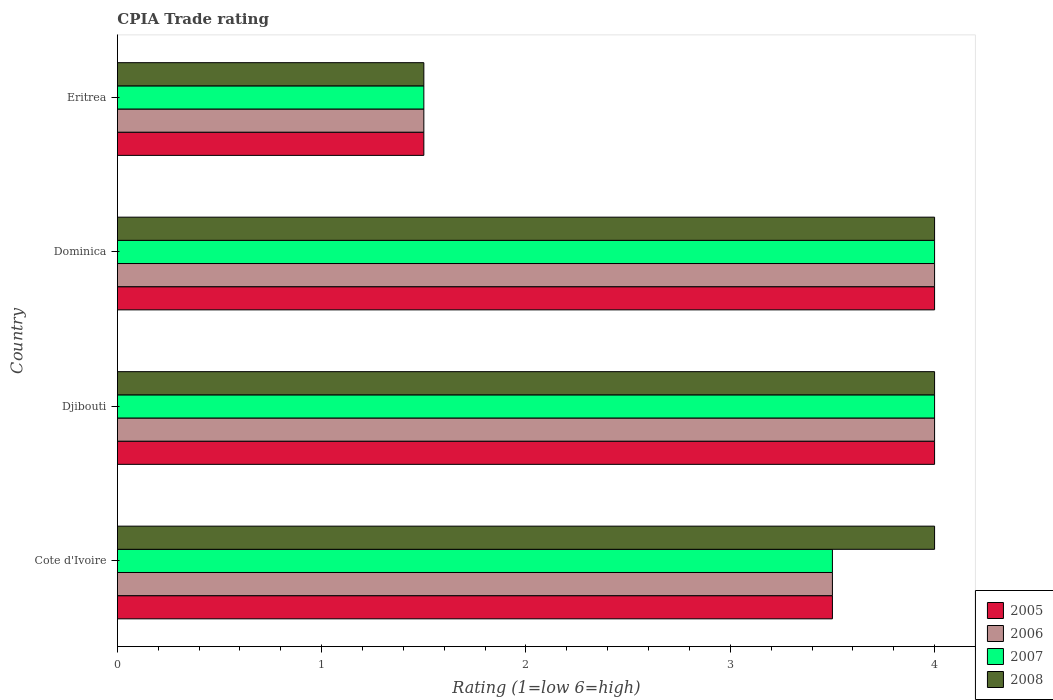How many different coloured bars are there?
Your answer should be very brief. 4. Are the number of bars on each tick of the Y-axis equal?
Give a very brief answer. Yes. How many bars are there on the 2nd tick from the top?
Your response must be concise. 4. How many bars are there on the 1st tick from the bottom?
Offer a very short reply. 4. What is the label of the 3rd group of bars from the top?
Ensure brevity in your answer.  Djibouti. What is the CPIA rating in 2007 in Cote d'Ivoire?
Your response must be concise. 3.5. In which country was the CPIA rating in 2006 maximum?
Your response must be concise. Djibouti. In which country was the CPIA rating in 2006 minimum?
Make the answer very short. Eritrea. What is the total CPIA rating in 2005 in the graph?
Keep it short and to the point. 13. What is the average CPIA rating in 2007 per country?
Your answer should be compact. 3.25. In how many countries, is the CPIA rating in 2008 greater than 3.6 ?
Offer a terse response. 3. What is the difference between the highest and the second highest CPIA rating in 2007?
Provide a short and direct response. 0. In how many countries, is the CPIA rating in 2005 greater than the average CPIA rating in 2005 taken over all countries?
Your response must be concise. 3. Is the sum of the CPIA rating in 2008 in Cote d'Ivoire and Eritrea greater than the maximum CPIA rating in 2007 across all countries?
Provide a succinct answer. Yes. Is it the case that in every country, the sum of the CPIA rating in 2007 and CPIA rating in 2006 is greater than the sum of CPIA rating in 2008 and CPIA rating in 2005?
Keep it short and to the point. No. What does the 4th bar from the top in Dominica represents?
Ensure brevity in your answer.  2005. How many bars are there?
Keep it short and to the point. 16. Are the values on the major ticks of X-axis written in scientific E-notation?
Offer a very short reply. No. Does the graph contain any zero values?
Offer a terse response. No. Where does the legend appear in the graph?
Provide a succinct answer. Bottom right. How many legend labels are there?
Your answer should be very brief. 4. How are the legend labels stacked?
Make the answer very short. Vertical. What is the title of the graph?
Keep it short and to the point. CPIA Trade rating. What is the label or title of the X-axis?
Offer a very short reply. Rating (1=low 6=high). What is the Rating (1=low 6=high) of 2008 in Cote d'Ivoire?
Provide a short and direct response. 4. What is the Rating (1=low 6=high) of 2007 in Djibouti?
Provide a succinct answer. 4. What is the Rating (1=low 6=high) in 2005 in Dominica?
Your response must be concise. 4. What is the Rating (1=low 6=high) in 2007 in Dominica?
Ensure brevity in your answer.  4. What is the Rating (1=low 6=high) in 2008 in Dominica?
Your response must be concise. 4. What is the Rating (1=low 6=high) in 2006 in Eritrea?
Your answer should be compact. 1.5. What is the Rating (1=low 6=high) in 2007 in Eritrea?
Provide a succinct answer. 1.5. What is the Rating (1=low 6=high) of 2008 in Eritrea?
Offer a very short reply. 1.5. Across all countries, what is the maximum Rating (1=low 6=high) of 2005?
Your answer should be very brief. 4. Across all countries, what is the maximum Rating (1=low 6=high) of 2007?
Your answer should be very brief. 4. What is the total Rating (1=low 6=high) in 2005 in the graph?
Ensure brevity in your answer.  13. What is the total Rating (1=low 6=high) of 2008 in the graph?
Provide a short and direct response. 13.5. What is the difference between the Rating (1=low 6=high) of 2005 in Cote d'Ivoire and that in Djibouti?
Give a very brief answer. -0.5. What is the difference between the Rating (1=low 6=high) in 2006 in Cote d'Ivoire and that in Djibouti?
Your answer should be very brief. -0.5. What is the difference between the Rating (1=low 6=high) in 2008 in Cote d'Ivoire and that in Djibouti?
Offer a very short reply. 0. What is the difference between the Rating (1=low 6=high) of 2005 in Cote d'Ivoire and that in Dominica?
Give a very brief answer. -0.5. What is the difference between the Rating (1=low 6=high) of 2007 in Cote d'Ivoire and that in Dominica?
Ensure brevity in your answer.  -0.5. What is the difference between the Rating (1=low 6=high) in 2008 in Cote d'Ivoire and that in Dominica?
Your response must be concise. 0. What is the difference between the Rating (1=low 6=high) of 2007 in Cote d'Ivoire and that in Eritrea?
Keep it short and to the point. 2. What is the difference between the Rating (1=low 6=high) in 2008 in Cote d'Ivoire and that in Eritrea?
Provide a short and direct response. 2.5. What is the difference between the Rating (1=low 6=high) in 2005 in Djibouti and that in Dominica?
Your answer should be very brief. 0. What is the difference between the Rating (1=low 6=high) of 2006 in Djibouti and that in Dominica?
Give a very brief answer. 0. What is the difference between the Rating (1=low 6=high) of 2007 in Djibouti and that in Dominica?
Keep it short and to the point. 0. What is the difference between the Rating (1=low 6=high) in 2008 in Djibouti and that in Dominica?
Ensure brevity in your answer.  0. What is the difference between the Rating (1=low 6=high) of 2005 in Djibouti and that in Eritrea?
Make the answer very short. 2.5. What is the difference between the Rating (1=low 6=high) in 2006 in Djibouti and that in Eritrea?
Keep it short and to the point. 2.5. What is the difference between the Rating (1=low 6=high) of 2008 in Djibouti and that in Eritrea?
Ensure brevity in your answer.  2.5. What is the difference between the Rating (1=low 6=high) of 2005 in Dominica and that in Eritrea?
Offer a very short reply. 2.5. What is the difference between the Rating (1=low 6=high) in 2007 in Dominica and that in Eritrea?
Provide a succinct answer. 2.5. What is the difference between the Rating (1=low 6=high) of 2008 in Dominica and that in Eritrea?
Give a very brief answer. 2.5. What is the difference between the Rating (1=low 6=high) of 2005 in Cote d'Ivoire and the Rating (1=low 6=high) of 2006 in Djibouti?
Give a very brief answer. -0.5. What is the difference between the Rating (1=low 6=high) in 2005 in Cote d'Ivoire and the Rating (1=low 6=high) in 2007 in Djibouti?
Your response must be concise. -0.5. What is the difference between the Rating (1=low 6=high) in 2006 in Cote d'Ivoire and the Rating (1=low 6=high) in 2007 in Djibouti?
Your answer should be compact. -0.5. What is the difference between the Rating (1=low 6=high) of 2005 in Cote d'Ivoire and the Rating (1=low 6=high) of 2006 in Dominica?
Give a very brief answer. -0.5. What is the difference between the Rating (1=low 6=high) in 2005 in Cote d'Ivoire and the Rating (1=low 6=high) in 2007 in Dominica?
Keep it short and to the point. -0.5. What is the difference between the Rating (1=low 6=high) in 2005 in Cote d'Ivoire and the Rating (1=low 6=high) in 2008 in Dominica?
Provide a succinct answer. -0.5. What is the difference between the Rating (1=low 6=high) of 2006 in Cote d'Ivoire and the Rating (1=low 6=high) of 2007 in Dominica?
Your answer should be very brief. -0.5. What is the difference between the Rating (1=low 6=high) in 2006 in Cote d'Ivoire and the Rating (1=low 6=high) in 2008 in Dominica?
Offer a very short reply. -0.5. What is the difference between the Rating (1=low 6=high) of 2007 in Cote d'Ivoire and the Rating (1=low 6=high) of 2008 in Dominica?
Your answer should be compact. -0.5. What is the difference between the Rating (1=low 6=high) in 2005 in Cote d'Ivoire and the Rating (1=low 6=high) in 2007 in Eritrea?
Your response must be concise. 2. What is the difference between the Rating (1=low 6=high) of 2006 in Cote d'Ivoire and the Rating (1=low 6=high) of 2007 in Eritrea?
Give a very brief answer. 2. What is the difference between the Rating (1=low 6=high) in 2006 in Cote d'Ivoire and the Rating (1=low 6=high) in 2008 in Eritrea?
Your response must be concise. 2. What is the difference between the Rating (1=low 6=high) in 2007 in Cote d'Ivoire and the Rating (1=low 6=high) in 2008 in Eritrea?
Provide a succinct answer. 2. What is the difference between the Rating (1=low 6=high) in 2005 in Djibouti and the Rating (1=low 6=high) in 2006 in Dominica?
Your answer should be very brief. 0. What is the difference between the Rating (1=low 6=high) in 2005 in Djibouti and the Rating (1=low 6=high) in 2007 in Dominica?
Provide a short and direct response. 0. What is the difference between the Rating (1=low 6=high) in 2005 in Djibouti and the Rating (1=low 6=high) in 2008 in Dominica?
Give a very brief answer. 0. What is the difference between the Rating (1=low 6=high) of 2006 in Djibouti and the Rating (1=low 6=high) of 2007 in Dominica?
Make the answer very short. 0. What is the difference between the Rating (1=low 6=high) of 2006 in Djibouti and the Rating (1=low 6=high) of 2008 in Dominica?
Ensure brevity in your answer.  0. What is the difference between the Rating (1=low 6=high) of 2005 in Djibouti and the Rating (1=low 6=high) of 2006 in Eritrea?
Your answer should be very brief. 2.5. What is the difference between the Rating (1=low 6=high) of 2005 in Djibouti and the Rating (1=low 6=high) of 2007 in Eritrea?
Give a very brief answer. 2.5. What is the difference between the Rating (1=low 6=high) of 2005 in Djibouti and the Rating (1=low 6=high) of 2008 in Eritrea?
Provide a succinct answer. 2.5. What is the difference between the Rating (1=low 6=high) in 2006 in Djibouti and the Rating (1=low 6=high) in 2007 in Eritrea?
Provide a short and direct response. 2.5. What is the difference between the Rating (1=low 6=high) of 2006 in Djibouti and the Rating (1=low 6=high) of 2008 in Eritrea?
Make the answer very short. 2.5. What is the difference between the Rating (1=low 6=high) of 2007 in Djibouti and the Rating (1=low 6=high) of 2008 in Eritrea?
Your answer should be very brief. 2.5. What is the difference between the Rating (1=low 6=high) in 2005 in Dominica and the Rating (1=low 6=high) in 2007 in Eritrea?
Your answer should be compact. 2.5. What is the average Rating (1=low 6=high) in 2006 per country?
Provide a short and direct response. 3.25. What is the average Rating (1=low 6=high) in 2007 per country?
Provide a succinct answer. 3.25. What is the average Rating (1=low 6=high) of 2008 per country?
Keep it short and to the point. 3.38. What is the difference between the Rating (1=low 6=high) of 2005 and Rating (1=low 6=high) of 2006 in Cote d'Ivoire?
Provide a succinct answer. 0. What is the difference between the Rating (1=low 6=high) of 2005 and Rating (1=low 6=high) of 2007 in Cote d'Ivoire?
Ensure brevity in your answer.  0. What is the difference between the Rating (1=low 6=high) of 2006 and Rating (1=low 6=high) of 2008 in Cote d'Ivoire?
Your response must be concise. -0.5. What is the difference between the Rating (1=low 6=high) of 2005 and Rating (1=low 6=high) of 2006 in Djibouti?
Provide a succinct answer. 0. What is the difference between the Rating (1=low 6=high) of 2005 and Rating (1=low 6=high) of 2007 in Djibouti?
Ensure brevity in your answer.  0. What is the difference between the Rating (1=low 6=high) of 2006 and Rating (1=low 6=high) of 2007 in Djibouti?
Your response must be concise. 0. What is the difference between the Rating (1=low 6=high) in 2005 and Rating (1=low 6=high) in 2006 in Dominica?
Offer a very short reply. 0. What is the difference between the Rating (1=low 6=high) of 2005 and Rating (1=low 6=high) of 2007 in Dominica?
Your response must be concise. 0. What is the difference between the Rating (1=low 6=high) of 2006 and Rating (1=low 6=high) of 2007 in Dominica?
Make the answer very short. 0. What is the difference between the Rating (1=low 6=high) of 2006 and Rating (1=low 6=high) of 2008 in Dominica?
Give a very brief answer. 0. What is the difference between the Rating (1=low 6=high) of 2007 and Rating (1=low 6=high) of 2008 in Dominica?
Keep it short and to the point. 0. What is the difference between the Rating (1=low 6=high) of 2005 and Rating (1=low 6=high) of 2006 in Eritrea?
Your response must be concise. 0. What is the difference between the Rating (1=low 6=high) of 2005 and Rating (1=low 6=high) of 2008 in Eritrea?
Offer a very short reply. 0. What is the difference between the Rating (1=low 6=high) of 2006 and Rating (1=low 6=high) of 2007 in Eritrea?
Provide a succinct answer. 0. What is the difference between the Rating (1=low 6=high) of 2006 and Rating (1=low 6=high) of 2008 in Eritrea?
Your answer should be very brief. 0. What is the difference between the Rating (1=low 6=high) in 2007 and Rating (1=low 6=high) in 2008 in Eritrea?
Your response must be concise. 0. What is the ratio of the Rating (1=low 6=high) of 2007 in Cote d'Ivoire to that in Djibouti?
Make the answer very short. 0.88. What is the ratio of the Rating (1=low 6=high) of 2008 in Cote d'Ivoire to that in Djibouti?
Provide a succinct answer. 1. What is the ratio of the Rating (1=low 6=high) of 2006 in Cote d'Ivoire to that in Dominica?
Ensure brevity in your answer.  0.88. What is the ratio of the Rating (1=low 6=high) of 2007 in Cote d'Ivoire to that in Dominica?
Offer a very short reply. 0.88. What is the ratio of the Rating (1=low 6=high) in 2008 in Cote d'Ivoire to that in Dominica?
Keep it short and to the point. 1. What is the ratio of the Rating (1=low 6=high) of 2005 in Cote d'Ivoire to that in Eritrea?
Provide a short and direct response. 2.33. What is the ratio of the Rating (1=low 6=high) in 2006 in Cote d'Ivoire to that in Eritrea?
Your answer should be very brief. 2.33. What is the ratio of the Rating (1=low 6=high) of 2007 in Cote d'Ivoire to that in Eritrea?
Give a very brief answer. 2.33. What is the ratio of the Rating (1=low 6=high) of 2008 in Cote d'Ivoire to that in Eritrea?
Give a very brief answer. 2.67. What is the ratio of the Rating (1=low 6=high) in 2006 in Djibouti to that in Dominica?
Provide a short and direct response. 1. What is the ratio of the Rating (1=low 6=high) of 2008 in Djibouti to that in Dominica?
Keep it short and to the point. 1. What is the ratio of the Rating (1=low 6=high) of 2005 in Djibouti to that in Eritrea?
Offer a very short reply. 2.67. What is the ratio of the Rating (1=low 6=high) of 2006 in Djibouti to that in Eritrea?
Keep it short and to the point. 2.67. What is the ratio of the Rating (1=low 6=high) in 2007 in Djibouti to that in Eritrea?
Make the answer very short. 2.67. What is the ratio of the Rating (1=low 6=high) of 2008 in Djibouti to that in Eritrea?
Offer a very short reply. 2.67. What is the ratio of the Rating (1=low 6=high) of 2005 in Dominica to that in Eritrea?
Provide a short and direct response. 2.67. What is the ratio of the Rating (1=low 6=high) of 2006 in Dominica to that in Eritrea?
Offer a terse response. 2.67. What is the ratio of the Rating (1=low 6=high) of 2007 in Dominica to that in Eritrea?
Make the answer very short. 2.67. What is the ratio of the Rating (1=low 6=high) of 2008 in Dominica to that in Eritrea?
Ensure brevity in your answer.  2.67. What is the difference between the highest and the second highest Rating (1=low 6=high) of 2005?
Your response must be concise. 0. What is the difference between the highest and the second highest Rating (1=low 6=high) of 2007?
Your answer should be compact. 0. What is the difference between the highest and the second highest Rating (1=low 6=high) of 2008?
Give a very brief answer. 0. 